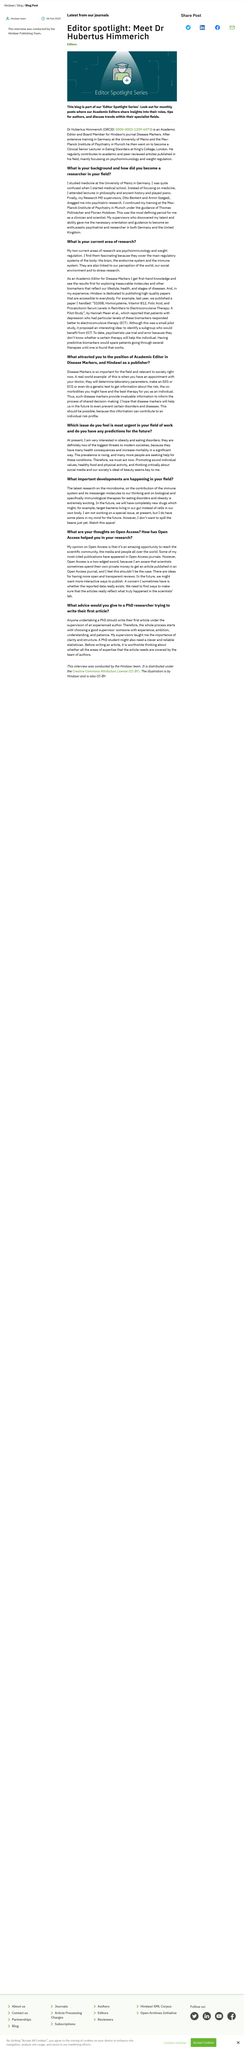Draw attention to some important aspects in this diagram. Dr. Hubertus Himmerich is an expert in the fields of psychoimmunology and weight regulation. The individual's supervisors at the Max-Planck-Institute of Psychiatry were Thomas Pollmacher and Florian Holsboer. This article's title is [insert title] and important developments are occurring in [insert field]. The academic editor's full name is Dr. Hubertus Himmerich, as mentioned in this post. The latest research on the microbiome is the topic of the title. 